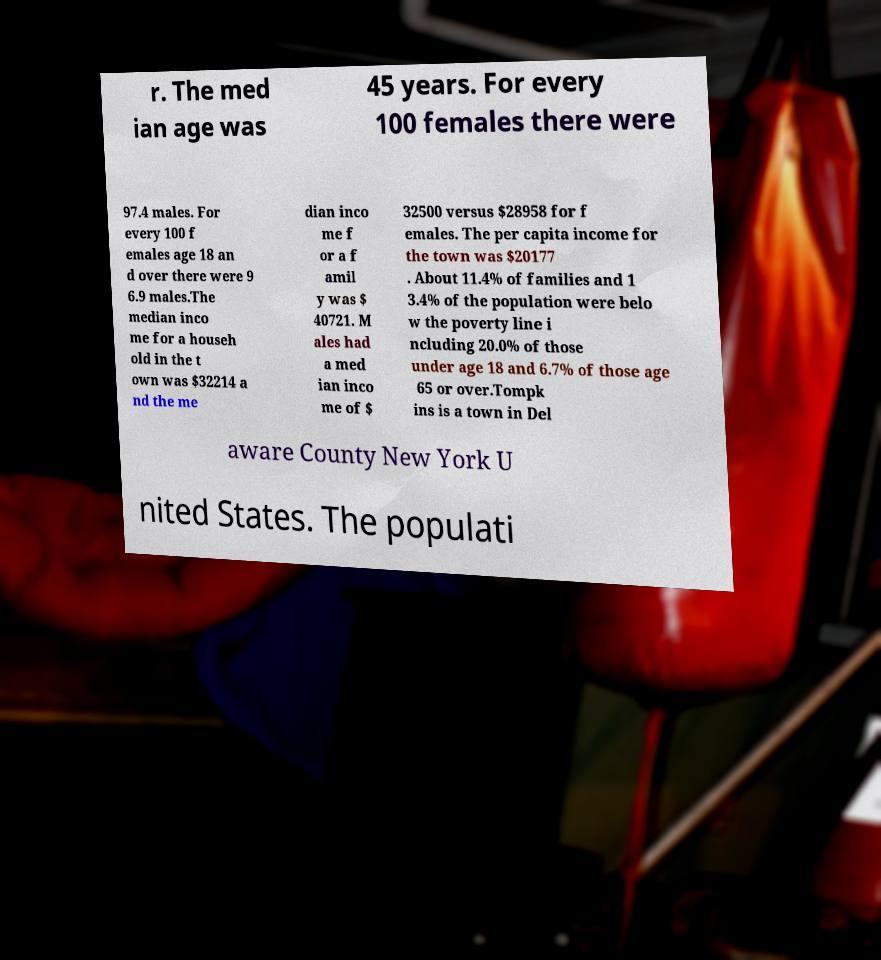Can you accurately transcribe the text from the provided image for me? r. The med ian age was 45 years. For every 100 females there were 97.4 males. For every 100 f emales age 18 an d over there were 9 6.9 males.The median inco me for a househ old in the t own was $32214 a nd the me dian inco me f or a f amil y was $ 40721. M ales had a med ian inco me of $ 32500 versus $28958 for f emales. The per capita income for the town was $20177 . About 11.4% of families and 1 3.4% of the population were belo w the poverty line i ncluding 20.0% of those under age 18 and 6.7% of those age 65 or over.Tompk ins is a town in Del aware County New York U nited States. The populati 